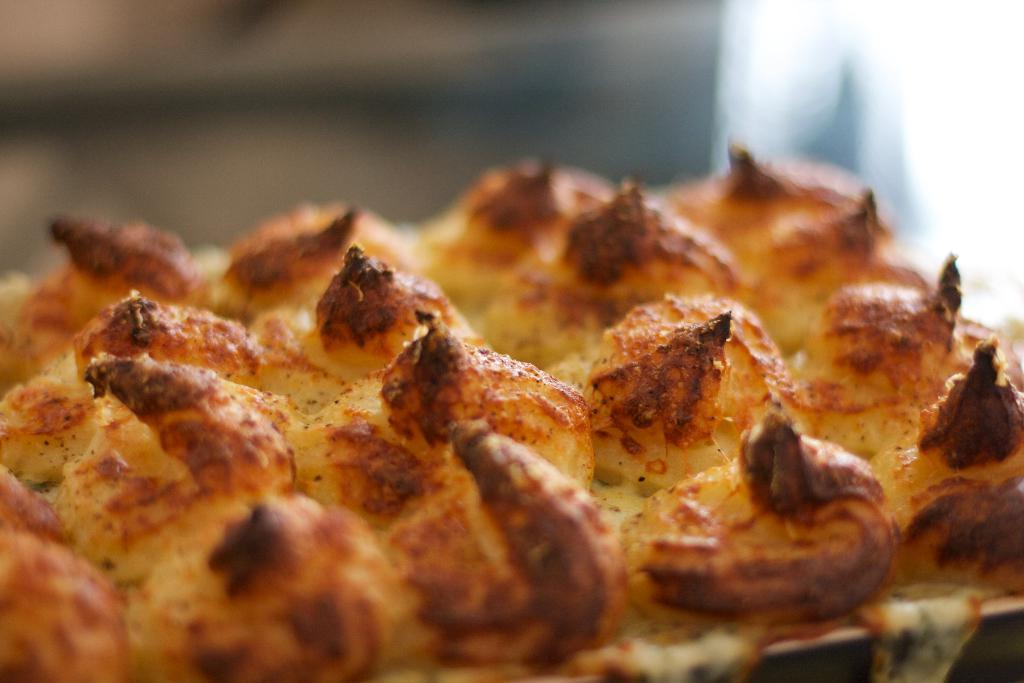What type of food is shown in the image? There is a pizza in the image. Can you describe the background of the image? The background of the image is blurry. What type of tool is being used to fix the underwear in the image? There is no tool or underwear present in the image; it only features a pizza. 